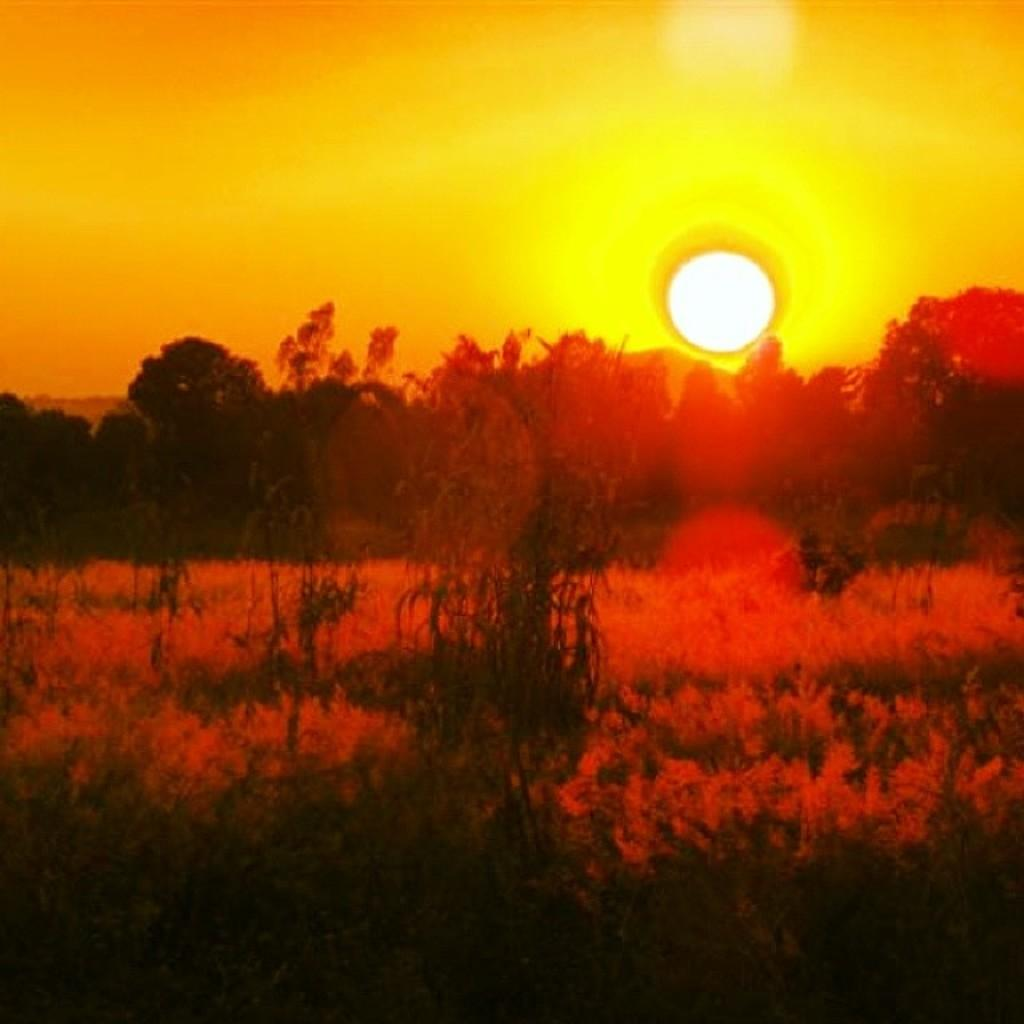What type of vegetation can be seen in the image? There are trees and plants on the ground in the image. What is the primary source of light in the image? The sun is visible in the sky, providing light. What type of machine can be seen operating in the image? There is no machine present in the image; it features trees, plants, and the sun. Is it raining in the image? There is no indication of rain in the image, as the sky is clear and the sun is visible. 